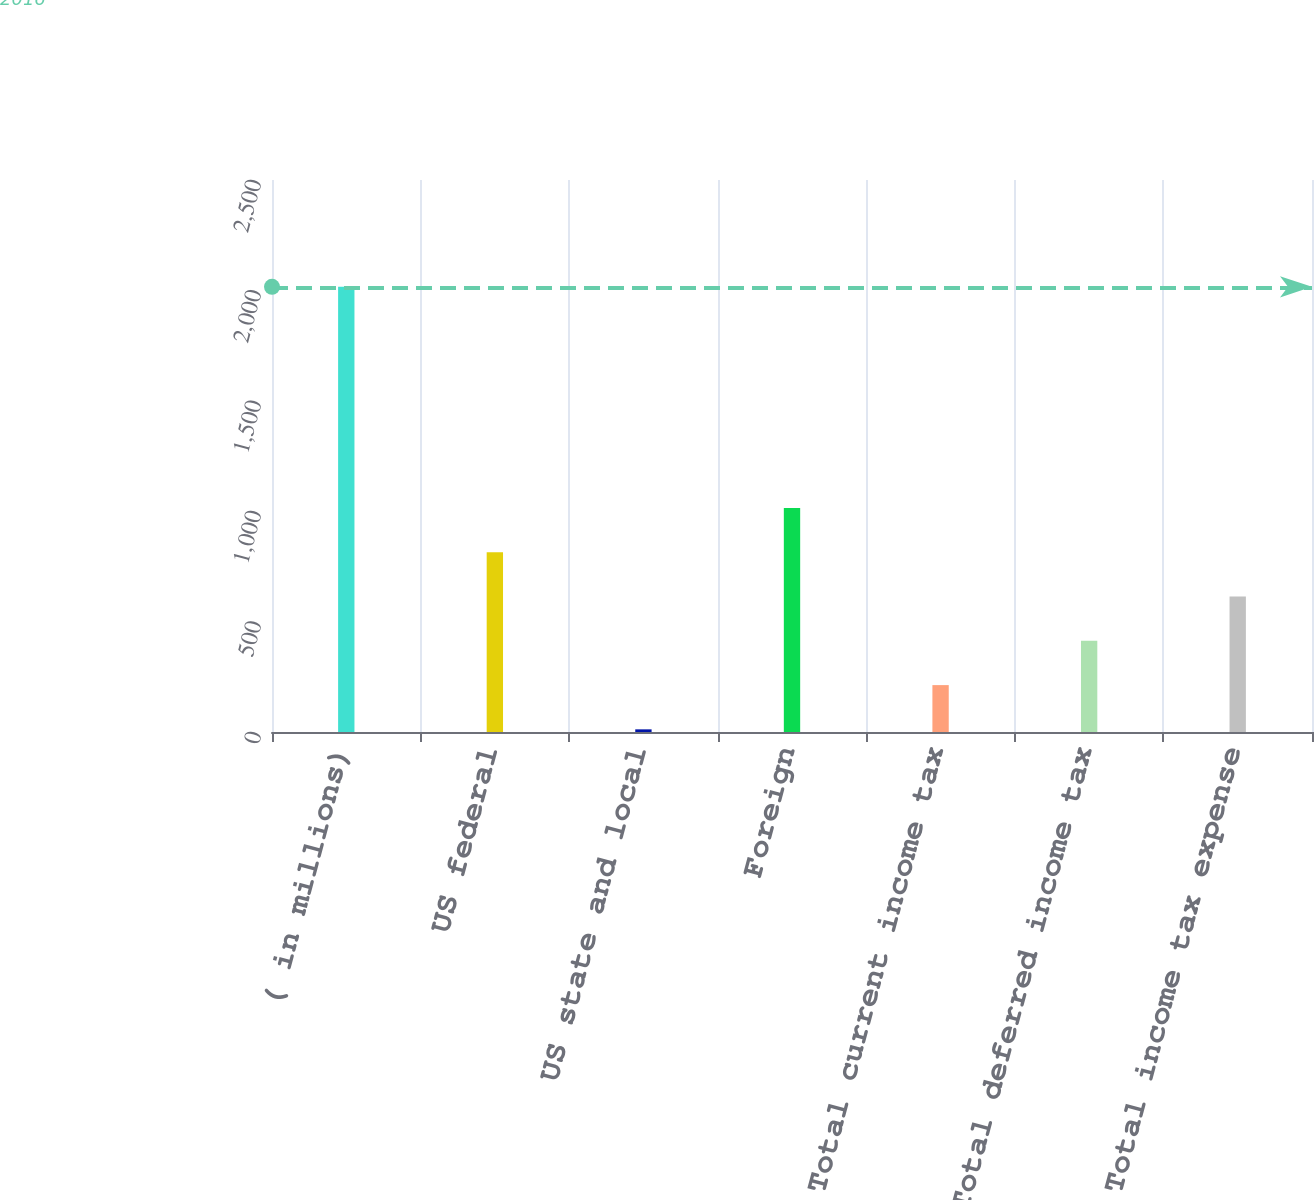Convert chart to OTSL. <chart><loc_0><loc_0><loc_500><loc_500><bar_chart><fcel>( in millions)<fcel>US federal<fcel>US state and local<fcel>Foreign<fcel>Total current income tax<fcel>Total deferred income tax<fcel>Total income tax expense<nl><fcel>2016<fcel>813.6<fcel>12<fcel>1014<fcel>212.4<fcel>412.8<fcel>613.2<nl></chart> 